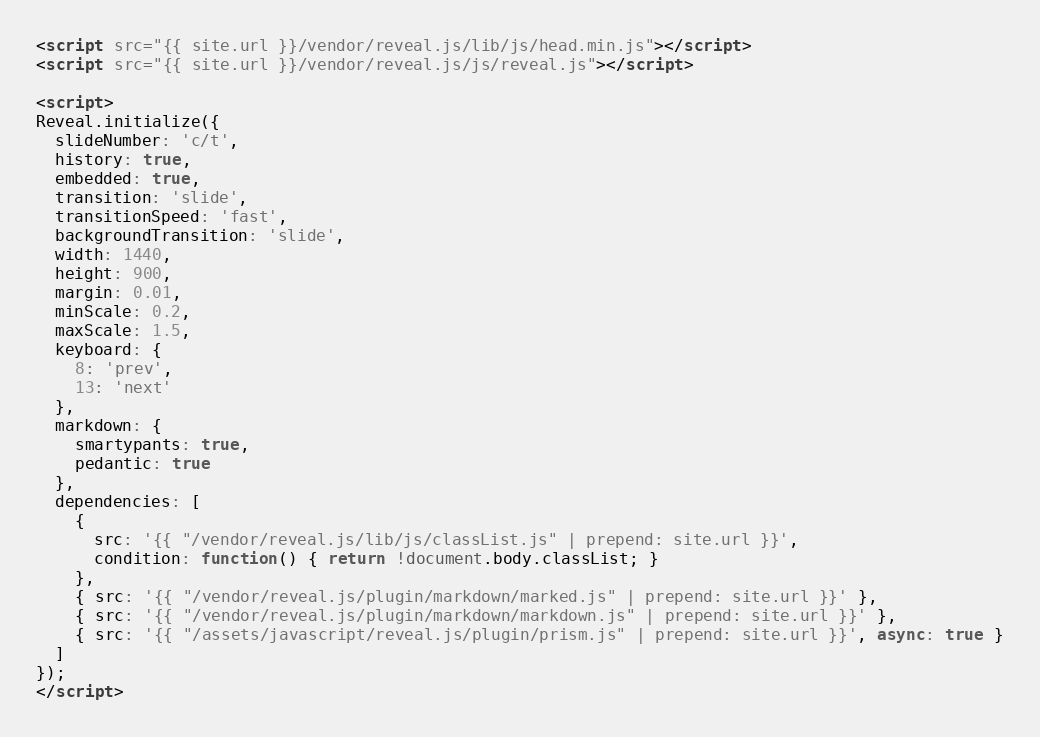<code> <loc_0><loc_0><loc_500><loc_500><_HTML_><script src="{{ site.url }}/vendor/reveal.js/lib/js/head.min.js"></script>
<script src="{{ site.url }}/vendor/reveal.js/js/reveal.js"></script>

<script>
Reveal.initialize({
  slideNumber: 'c/t',
  history: true,
  embedded: true,
  transition: 'slide',
  transitionSpeed: 'fast',
  backgroundTransition: 'slide',
  width: 1440,
  height: 900,
  margin: 0.01,
  minScale: 0.2,
  maxScale: 1.5,
  keyboard: {
    8: 'prev',
    13: 'next'
  },
  markdown: {
    smartypants: true,
    pedantic: true
  },
  dependencies: [
    {
      src: '{{ "/vendor/reveal.js/lib/js/classList.js" | prepend: site.url }}',
      condition: function() { return !document.body.classList; }
    },
    { src: '{{ "/vendor/reveal.js/plugin/markdown/marked.js" | prepend: site.url }}' },
    { src: '{{ "/vendor/reveal.js/plugin/markdown/markdown.js" | prepend: site.url }}' },
    { src: '{{ "/assets/javascript/reveal.js/plugin/prism.js" | prepend: site.url }}', async: true }
  ]
});
</script>
</code> 